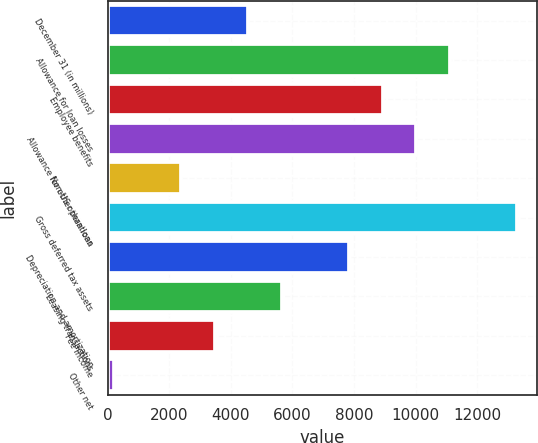<chart> <loc_0><loc_0><loc_500><loc_500><bar_chart><fcel>December 31 (in millions)<fcel>Allowance for loan losses<fcel>Employee benefits<fcel>Allowance for other than loan<fcel>Non-US operations<fcel>Gross deferred tax assets<fcel>Depreciation and amortization<fcel>Leasing transactions<fcel>Fee income<fcel>Other net<nl><fcel>4568.6<fcel>11111<fcel>8930.2<fcel>10020.6<fcel>2387.8<fcel>13291.8<fcel>7839.8<fcel>5659<fcel>3478.2<fcel>207<nl></chart> 